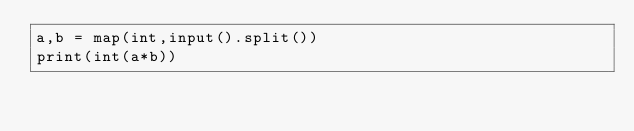<code> <loc_0><loc_0><loc_500><loc_500><_Python_>a,b = map(int,input().split())
print(int(a*b))</code> 